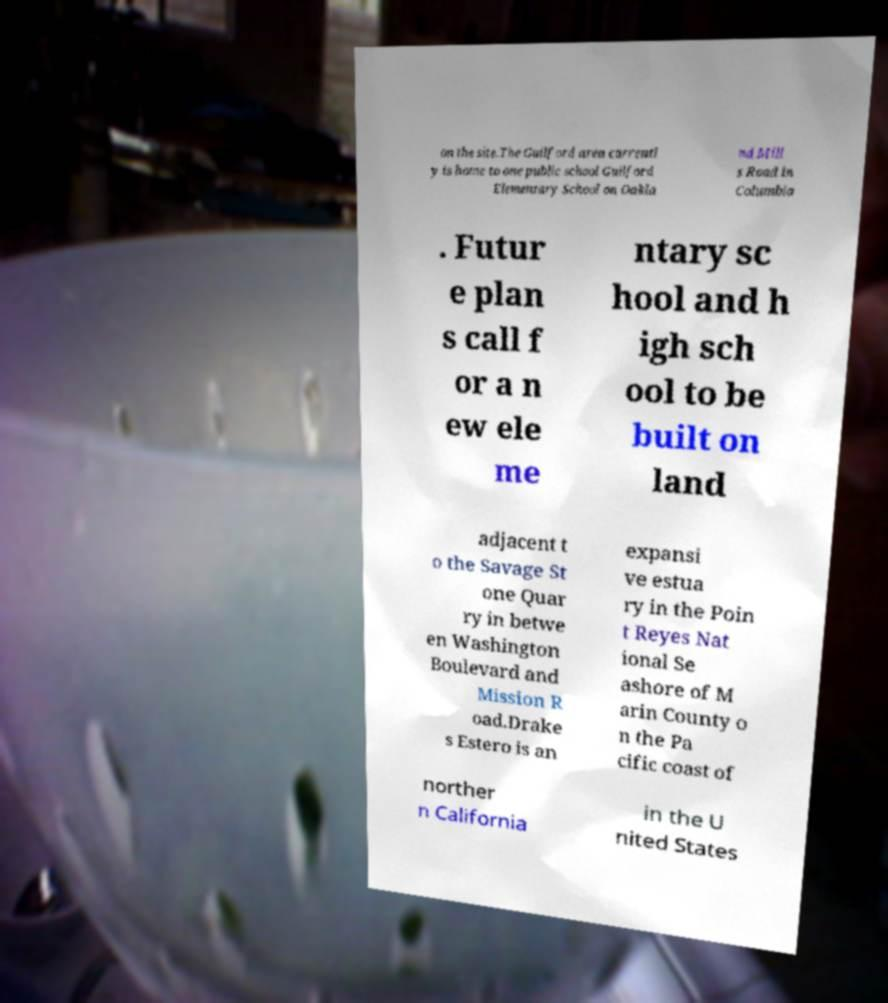There's text embedded in this image that I need extracted. Can you transcribe it verbatim? on the site.The Guilford area currentl y is home to one public school Guilford Elementary School on Oakla nd Mill s Road in Columbia . Futur e plan s call f or a n ew ele me ntary sc hool and h igh sch ool to be built on land adjacent t o the Savage St one Quar ry in betwe en Washington Boulevard and Mission R oad.Drake s Estero is an expansi ve estua ry in the Poin t Reyes Nat ional Se ashore of M arin County o n the Pa cific coast of norther n California in the U nited States 